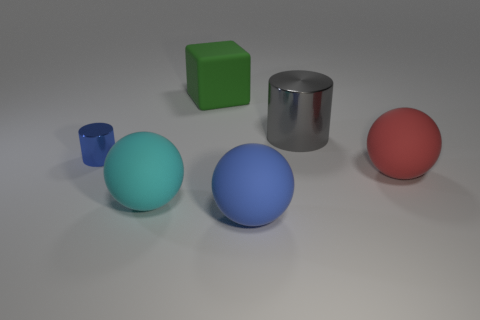Add 2 cylinders. How many objects exist? 8 Subtract all cylinders. How many objects are left? 4 Add 2 cylinders. How many cylinders exist? 4 Subtract 0 red blocks. How many objects are left? 6 Subtract all matte objects. Subtract all small red shiny blocks. How many objects are left? 2 Add 5 big shiny cylinders. How many big shiny cylinders are left? 6 